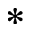<formula> <loc_0><loc_0><loc_500><loc_500>\ast</formula> 